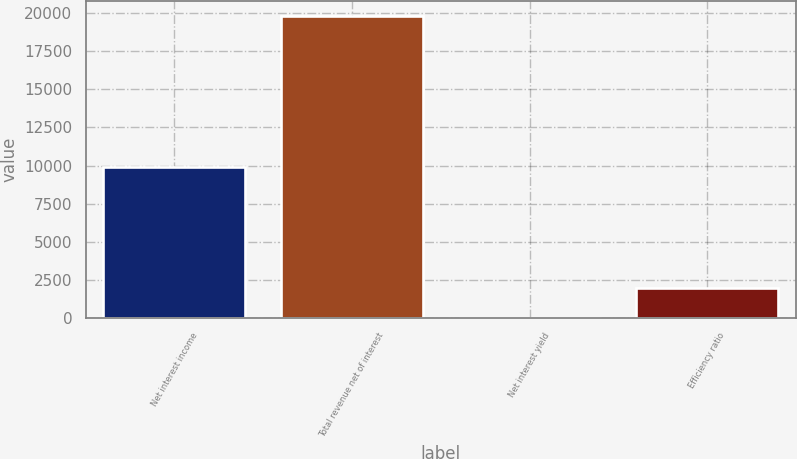Convert chart. <chart><loc_0><loc_0><loc_500><loc_500><bar_chart><fcel>Net interest income<fcel>Total revenue net of interest<fcel>Net interest yield<fcel>Efficiency ratio<nl><fcel>9911<fcel>19807<fcel>2.14<fcel>1982.63<nl></chart> 